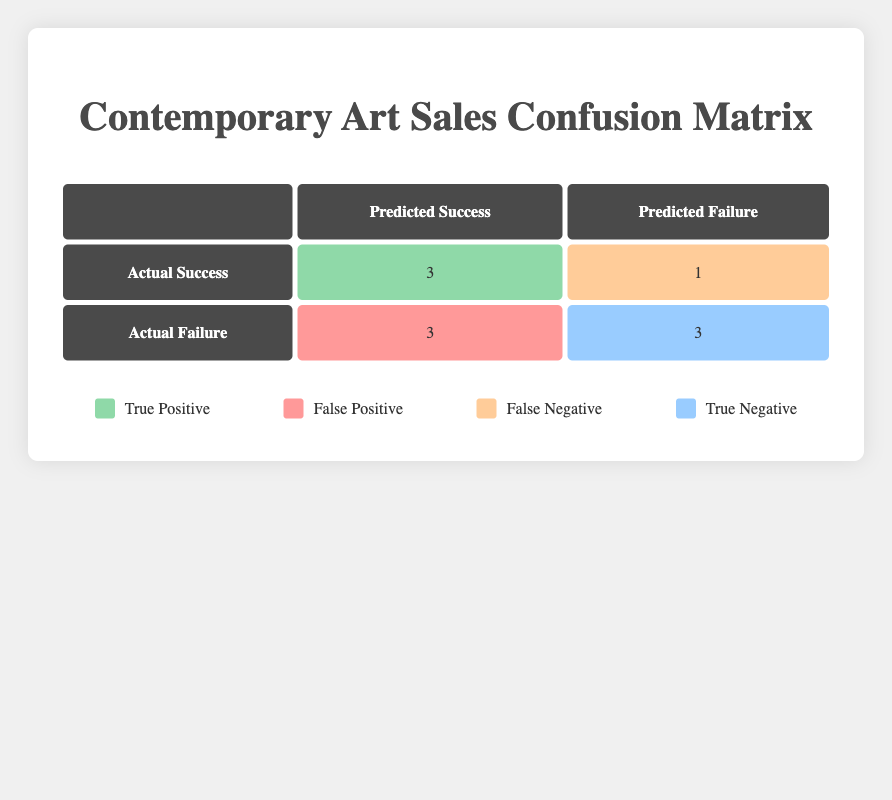What is the number of true positives in the confusion matrix? The table shows that there are 3 true positives, as indicated in the cell where actual success intersects with predicted success.
Answer: 3 How many genres are classified as "false positives"? Looking at the table, the false positives are listed under the actual failure row with predicted success, which shows 3 genres.
Answer: 3 What is the total number of actual successes? The total actual successes can be found by adding the true positives and false negatives from the table. That is 3 (true positives) + 1 (false negatives) = 4.
Answer: 4 Is "Digital Art" classified as a true negative? The table does not list "Digital Art" in the true negative cell since it shows a false negative instead; therefore, it is not classified as a true negative.
Answer: No What is the ratio of true positives to false negatives? To find the ratio, divide the number of true positives, which is 3, by the number of false negatives, which is 1. This gives a ratio of 3:1.
Answer: 3:1 How many genres have been successful according to the predictions made? The table indicates that there are 3 true positives (where the prediction was successful and it was indeed successful) and 3 false positives (where the prediction was successful but it was a failure). Thus, a total of 6 genres have been predicted as successful.
Answer: 6 Are there any genres that were predicted to fail but were actually successful? Yes, "Digital Art" is an example of a genre that was predicted to fail (false negative) but was actually successful.
Answer: Yes What percentage of actual failures was predicted correctly? To find this percentage, calculate the true negatives (3) over the total actual failures (3 false positives + 3 true negatives = 6): (3/6) * 100 = 50%.
Answer: 50% 